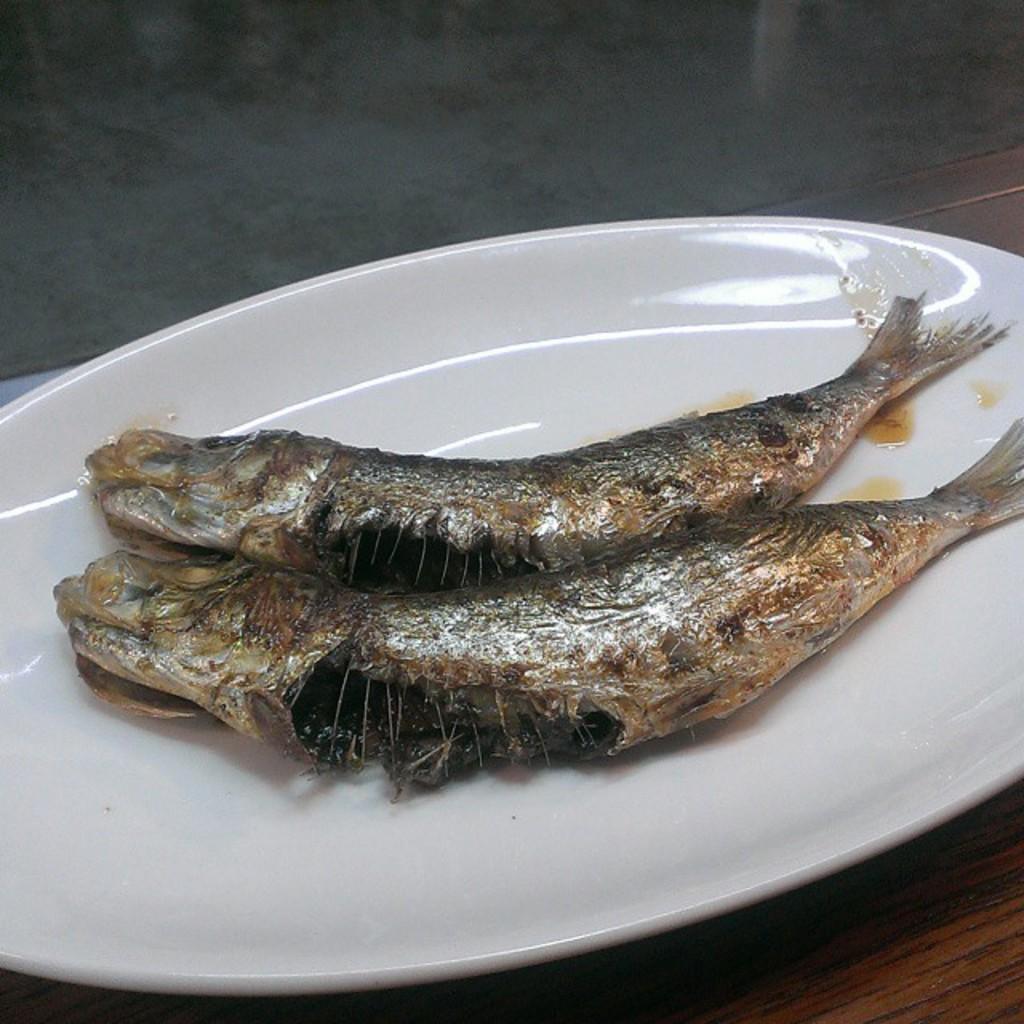In one or two sentences, can you explain what this image depicts? In this image we can see two cooked fishes in a white color plate. 